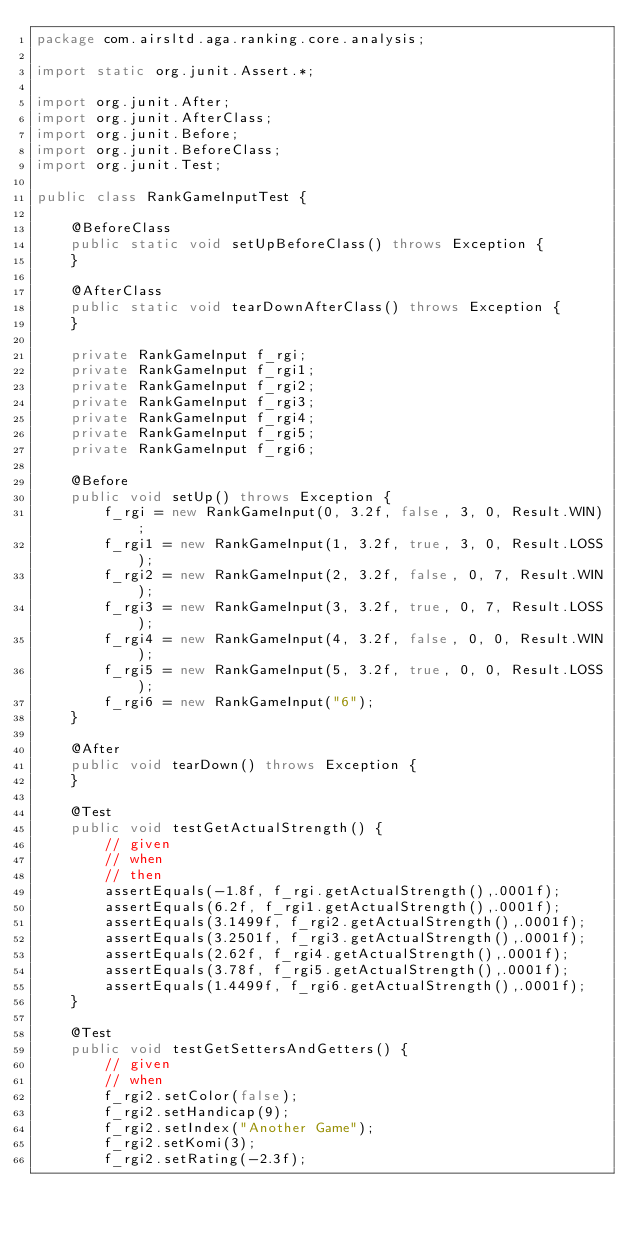<code> <loc_0><loc_0><loc_500><loc_500><_Java_>package com.airsltd.aga.ranking.core.analysis;

import static org.junit.Assert.*;

import org.junit.After;
import org.junit.AfterClass;
import org.junit.Before;
import org.junit.BeforeClass;
import org.junit.Test;

public class RankGameInputTest {

	@BeforeClass
	public static void setUpBeforeClass() throws Exception {
	}

	@AfterClass
	public static void tearDownAfterClass() throws Exception {
	}

	private RankGameInput f_rgi;
	private RankGameInput f_rgi1;
	private RankGameInput f_rgi2;
	private RankGameInput f_rgi3;
	private RankGameInput f_rgi4;
	private RankGameInput f_rgi5;
	private RankGameInput f_rgi6;

	@Before
	public void setUp() throws Exception {
		f_rgi = new RankGameInput(0, 3.2f, false, 3, 0, Result.WIN);
		f_rgi1 = new RankGameInput(1, 3.2f, true, 3, 0, Result.LOSS);
		f_rgi2 = new RankGameInput(2, 3.2f, false, 0, 7, Result.WIN);
		f_rgi3 = new RankGameInput(3, 3.2f, true, 0, 7, Result.LOSS);
		f_rgi4 = new RankGameInput(4, 3.2f, false, 0, 0, Result.WIN);
		f_rgi5 = new RankGameInput(5, 3.2f, true, 0, 0, Result.LOSS);
		f_rgi6 = new RankGameInput("6");
	}

	@After
	public void tearDown() throws Exception {
	}

	@Test
	public void testGetActualStrength() {
		// given
		// when
		// then
		assertEquals(-1.8f, f_rgi.getActualStrength(),.0001f);
		assertEquals(6.2f, f_rgi1.getActualStrength(),.0001f);
		assertEquals(3.1499f, f_rgi2.getActualStrength(),.0001f);
		assertEquals(3.2501f, f_rgi3.getActualStrength(),.0001f);
		assertEquals(2.62f, f_rgi4.getActualStrength(),.0001f);
		assertEquals(3.78f, f_rgi5.getActualStrength(),.0001f);
		assertEquals(1.4499f, f_rgi6.getActualStrength(),.0001f);
	}

	@Test
	public void testGetSettersAndGetters() {
		// given
		// when
		f_rgi2.setColor(false);
		f_rgi2.setHandicap(9);
		f_rgi2.setIndex("Another Game");
		f_rgi2.setKomi(3);
		f_rgi2.setRating(-2.3f);</code> 